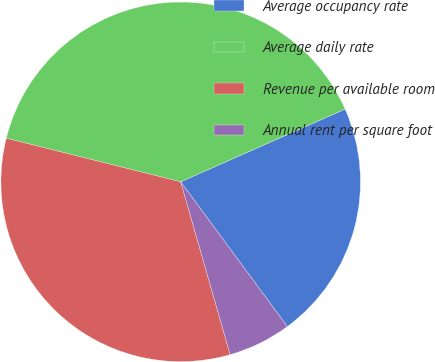<chart> <loc_0><loc_0><loc_500><loc_500><pie_chart><fcel>Average occupancy rate<fcel>Average daily rate<fcel>Revenue per available room<fcel>Annual rent per square foot<nl><fcel>21.52%<fcel>39.47%<fcel>33.33%<fcel>5.67%<nl></chart> 